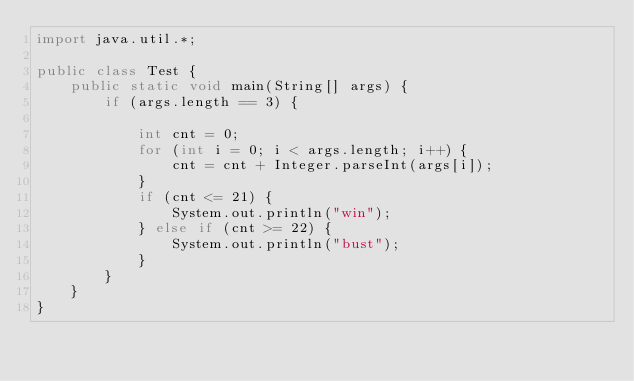Convert code to text. <code><loc_0><loc_0><loc_500><loc_500><_Java_>import java.util.*;

public class Test {
    public static void main(String[] args) {
        if (args.length == 3) {

            int cnt = 0;
            for (int i = 0; i < args.length; i++) {
                cnt = cnt + Integer.parseInt(args[i]);
            }
            if (cnt <= 21) {
                System.out.println("win");
            } else if (cnt >= 22) {
                System.out.println("bust");
            }
        }
    }
}</code> 